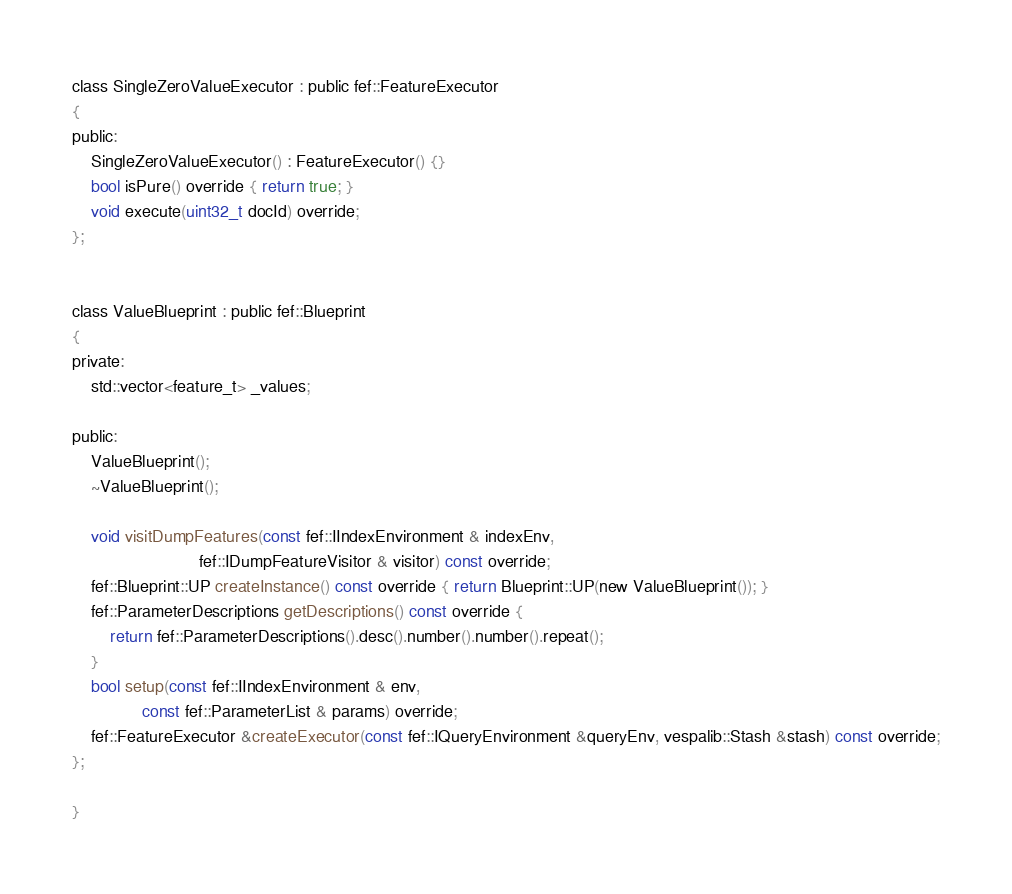Convert code to text. <code><loc_0><loc_0><loc_500><loc_500><_C_>class SingleZeroValueExecutor : public fef::FeatureExecutor
{
public:
    SingleZeroValueExecutor() : FeatureExecutor() {}
    bool isPure() override { return true; }
    void execute(uint32_t docId) override;
};


class ValueBlueprint : public fef::Blueprint
{
private:
    std::vector<feature_t> _values;

public:
    ValueBlueprint();
    ~ValueBlueprint();

    void visitDumpFeatures(const fef::IIndexEnvironment & indexEnv,
                           fef::IDumpFeatureVisitor & visitor) const override;
    fef::Blueprint::UP createInstance() const override { return Blueprint::UP(new ValueBlueprint()); }
    fef::ParameterDescriptions getDescriptions() const override {
        return fef::ParameterDescriptions().desc().number().number().repeat();
    }
    bool setup(const fef::IIndexEnvironment & env,
               const fef::ParameterList & params) override;
    fef::FeatureExecutor &createExecutor(const fef::IQueryEnvironment &queryEnv, vespalib::Stash &stash) const override;
};

}
</code> 